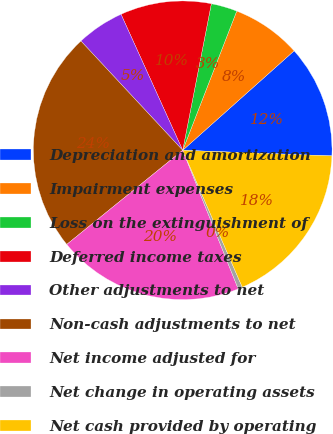Convert chart to OTSL. <chart><loc_0><loc_0><loc_500><loc_500><pie_chart><fcel>Depreciation and amortization<fcel>Impairment expenses<fcel>Loss on the extinguishment of<fcel>Deferred income taxes<fcel>Other adjustments to net<fcel>Non-cash adjustments to net<fcel>Net income adjusted for<fcel>Net change in operating assets<fcel>Net cash provided by operating<nl><fcel>12.2%<fcel>7.51%<fcel>2.82%<fcel>9.85%<fcel>5.16%<fcel>23.92%<fcel>20.21%<fcel>0.47%<fcel>17.87%<nl></chart> 